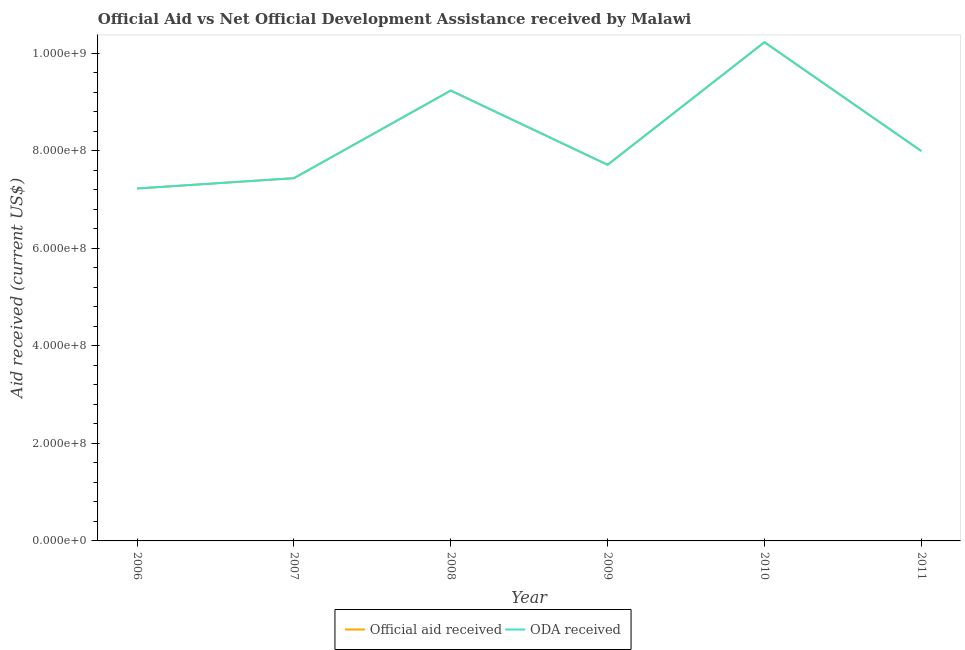Is the number of lines equal to the number of legend labels?
Offer a terse response. Yes. What is the oda received in 2006?
Offer a very short reply. 7.23e+08. Across all years, what is the maximum official aid received?
Give a very brief answer. 1.02e+09. Across all years, what is the minimum oda received?
Your response must be concise. 7.23e+08. What is the total oda received in the graph?
Offer a very short reply. 4.98e+09. What is the difference between the oda received in 2008 and that in 2009?
Ensure brevity in your answer.  1.52e+08. What is the difference between the official aid received in 2007 and the oda received in 2011?
Ensure brevity in your answer.  -5.57e+07. What is the average official aid received per year?
Provide a succinct answer. 8.31e+08. In the year 2007, what is the difference between the oda received and official aid received?
Offer a terse response. 0. What is the ratio of the official aid received in 2007 to that in 2010?
Give a very brief answer. 0.73. What is the difference between the highest and the second highest oda received?
Provide a succinct answer. 9.92e+07. What is the difference between the highest and the lowest oda received?
Keep it short and to the point. 3.00e+08. In how many years, is the oda received greater than the average oda received taken over all years?
Your answer should be very brief. 2. Are the values on the major ticks of Y-axis written in scientific E-notation?
Keep it short and to the point. Yes. Does the graph contain any zero values?
Offer a terse response. No. Where does the legend appear in the graph?
Your response must be concise. Bottom center. How are the legend labels stacked?
Ensure brevity in your answer.  Horizontal. What is the title of the graph?
Your answer should be compact. Official Aid vs Net Official Development Assistance received by Malawi . Does "All education staff compensation" appear as one of the legend labels in the graph?
Keep it short and to the point. No. What is the label or title of the Y-axis?
Make the answer very short. Aid received (current US$). What is the Aid received (current US$) of Official aid received in 2006?
Offer a very short reply. 7.23e+08. What is the Aid received (current US$) of ODA received in 2006?
Provide a succinct answer. 7.23e+08. What is the Aid received (current US$) in Official aid received in 2007?
Offer a terse response. 7.44e+08. What is the Aid received (current US$) in ODA received in 2007?
Give a very brief answer. 7.44e+08. What is the Aid received (current US$) of Official aid received in 2008?
Provide a succinct answer. 9.24e+08. What is the Aid received (current US$) of ODA received in 2008?
Make the answer very short. 9.24e+08. What is the Aid received (current US$) in Official aid received in 2009?
Your answer should be compact. 7.71e+08. What is the Aid received (current US$) of ODA received in 2009?
Ensure brevity in your answer.  7.71e+08. What is the Aid received (current US$) of Official aid received in 2010?
Your response must be concise. 1.02e+09. What is the Aid received (current US$) in ODA received in 2010?
Keep it short and to the point. 1.02e+09. What is the Aid received (current US$) in Official aid received in 2011?
Make the answer very short. 8.00e+08. What is the Aid received (current US$) in ODA received in 2011?
Offer a terse response. 8.00e+08. Across all years, what is the maximum Aid received (current US$) in Official aid received?
Offer a very short reply. 1.02e+09. Across all years, what is the maximum Aid received (current US$) in ODA received?
Offer a very short reply. 1.02e+09. Across all years, what is the minimum Aid received (current US$) in Official aid received?
Keep it short and to the point. 7.23e+08. Across all years, what is the minimum Aid received (current US$) of ODA received?
Give a very brief answer. 7.23e+08. What is the total Aid received (current US$) in Official aid received in the graph?
Give a very brief answer. 4.98e+09. What is the total Aid received (current US$) in ODA received in the graph?
Make the answer very short. 4.98e+09. What is the difference between the Aid received (current US$) of Official aid received in 2006 and that in 2007?
Your answer should be compact. -2.12e+07. What is the difference between the Aid received (current US$) in ODA received in 2006 and that in 2007?
Your answer should be compact. -2.12e+07. What is the difference between the Aid received (current US$) in Official aid received in 2006 and that in 2008?
Provide a short and direct response. -2.01e+08. What is the difference between the Aid received (current US$) of ODA received in 2006 and that in 2008?
Keep it short and to the point. -2.01e+08. What is the difference between the Aid received (current US$) in Official aid received in 2006 and that in 2009?
Your answer should be very brief. -4.86e+07. What is the difference between the Aid received (current US$) in ODA received in 2006 and that in 2009?
Keep it short and to the point. -4.86e+07. What is the difference between the Aid received (current US$) of Official aid received in 2006 and that in 2010?
Offer a terse response. -3.00e+08. What is the difference between the Aid received (current US$) in ODA received in 2006 and that in 2010?
Provide a succinct answer. -3.00e+08. What is the difference between the Aid received (current US$) in Official aid received in 2006 and that in 2011?
Offer a terse response. -7.68e+07. What is the difference between the Aid received (current US$) of ODA received in 2006 and that in 2011?
Ensure brevity in your answer.  -7.68e+07. What is the difference between the Aid received (current US$) of Official aid received in 2007 and that in 2008?
Your answer should be very brief. -1.80e+08. What is the difference between the Aid received (current US$) of ODA received in 2007 and that in 2008?
Your response must be concise. -1.80e+08. What is the difference between the Aid received (current US$) in Official aid received in 2007 and that in 2009?
Your response must be concise. -2.74e+07. What is the difference between the Aid received (current US$) in ODA received in 2007 and that in 2009?
Keep it short and to the point. -2.74e+07. What is the difference between the Aid received (current US$) of Official aid received in 2007 and that in 2010?
Give a very brief answer. -2.79e+08. What is the difference between the Aid received (current US$) of ODA received in 2007 and that in 2010?
Your response must be concise. -2.79e+08. What is the difference between the Aid received (current US$) of Official aid received in 2007 and that in 2011?
Ensure brevity in your answer.  -5.57e+07. What is the difference between the Aid received (current US$) of ODA received in 2007 and that in 2011?
Provide a short and direct response. -5.57e+07. What is the difference between the Aid received (current US$) of Official aid received in 2008 and that in 2009?
Offer a terse response. 1.52e+08. What is the difference between the Aid received (current US$) in ODA received in 2008 and that in 2009?
Your answer should be compact. 1.52e+08. What is the difference between the Aid received (current US$) in Official aid received in 2008 and that in 2010?
Provide a short and direct response. -9.92e+07. What is the difference between the Aid received (current US$) in ODA received in 2008 and that in 2010?
Keep it short and to the point. -9.92e+07. What is the difference between the Aid received (current US$) in Official aid received in 2008 and that in 2011?
Make the answer very short. 1.24e+08. What is the difference between the Aid received (current US$) in ODA received in 2008 and that in 2011?
Offer a terse response. 1.24e+08. What is the difference between the Aid received (current US$) in Official aid received in 2009 and that in 2010?
Offer a very short reply. -2.51e+08. What is the difference between the Aid received (current US$) in ODA received in 2009 and that in 2010?
Give a very brief answer. -2.51e+08. What is the difference between the Aid received (current US$) in Official aid received in 2009 and that in 2011?
Offer a terse response. -2.82e+07. What is the difference between the Aid received (current US$) in ODA received in 2009 and that in 2011?
Offer a very short reply. -2.82e+07. What is the difference between the Aid received (current US$) in Official aid received in 2010 and that in 2011?
Your response must be concise. 2.23e+08. What is the difference between the Aid received (current US$) in ODA received in 2010 and that in 2011?
Offer a very short reply. 2.23e+08. What is the difference between the Aid received (current US$) in Official aid received in 2006 and the Aid received (current US$) in ODA received in 2007?
Offer a very short reply. -2.12e+07. What is the difference between the Aid received (current US$) of Official aid received in 2006 and the Aid received (current US$) of ODA received in 2008?
Ensure brevity in your answer.  -2.01e+08. What is the difference between the Aid received (current US$) of Official aid received in 2006 and the Aid received (current US$) of ODA received in 2009?
Your answer should be compact. -4.86e+07. What is the difference between the Aid received (current US$) in Official aid received in 2006 and the Aid received (current US$) in ODA received in 2010?
Your answer should be compact. -3.00e+08. What is the difference between the Aid received (current US$) in Official aid received in 2006 and the Aid received (current US$) in ODA received in 2011?
Offer a terse response. -7.68e+07. What is the difference between the Aid received (current US$) in Official aid received in 2007 and the Aid received (current US$) in ODA received in 2008?
Offer a very short reply. -1.80e+08. What is the difference between the Aid received (current US$) of Official aid received in 2007 and the Aid received (current US$) of ODA received in 2009?
Provide a succinct answer. -2.74e+07. What is the difference between the Aid received (current US$) in Official aid received in 2007 and the Aid received (current US$) in ODA received in 2010?
Your answer should be compact. -2.79e+08. What is the difference between the Aid received (current US$) in Official aid received in 2007 and the Aid received (current US$) in ODA received in 2011?
Give a very brief answer. -5.57e+07. What is the difference between the Aid received (current US$) of Official aid received in 2008 and the Aid received (current US$) of ODA received in 2009?
Offer a very short reply. 1.52e+08. What is the difference between the Aid received (current US$) of Official aid received in 2008 and the Aid received (current US$) of ODA received in 2010?
Your response must be concise. -9.92e+07. What is the difference between the Aid received (current US$) in Official aid received in 2008 and the Aid received (current US$) in ODA received in 2011?
Offer a terse response. 1.24e+08. What is the difference between the Aid received (current US$) in Official aid received in 2009 and the Aid received (current US$) in ODA received in 2010?
Provide a succinct answer. -2.51e+08. What is the difference between the Aid received (current US$) in Official aid received in 2009 and the Aid received (current US$) in ODA received in 2011?
Your answer should be compact. -2.82e+07. What is the difference between the Aid received (current US$) in Official aid received in 2010 and the Aid received (current US$) in ODA received in 2011?
Give a very brief answer. 2.23e+08. What is the average Aid received (current US$) in Official aid received per year?
Give a very brief answer. 8.31e+08. What is the average Aid received (current US$) of ODA received per year?
Provide a short and direct response. 8.31e+08. In the year 2006, what is the difference between the Aid received (current US$) of Official aid received and Aid received (current US$) of ODA received?
Keep it short and to the point. 0. In the year 2007, what is the difference between the Aid received (current US$) of Official aid received and Aid received (current US$) of ODA received?
Make the answer very short. 0. In the year 2008, what is the difference between the Aid received (current US$) of Official aid received and Aid received (current US$) of ODA received?
Provide a short and direct response. 0. What is the ratio of the Aid received (current US$) of Official aid received in 2006 to that in 2007?
Ensure brevity in your answer.  0.97. What is the ratio of the Aid received (current US$) of ODA received in 2006 to that in 2007?
Ensure brevity in your answer.  0.97. What is the ratio of the Aid received (current US$) of Official aid received in 2006 to that in 2008?
Offer a terse response. 0.78. What is the ratio of the Aid received (current US$) of ODA received in 2006 to that in 2008?
Make the answer very short. 0.78. What is the ratio of the Aid received (current US$) of Official aid received in 2006 to that in 2009?
Offer a very short reply. 0.94. What is the ratio of the Aid received (current US$) in ODA received in 2006 to that in 2009?
Your answer should be compact. 0.94. What is the ratio of the Aid received (current US$) in Official aid received in 2006 to that in 2010?
Keep it short and to the point. 0.71. What is the ratio of the Aid received (current US$) of ODA received in 2006 to that in 2010?
Provide a succinct answer. 0.71. What is the ratio of the Aid received (current US$) in Official aid received in 2006 to that in 2011?
Offer a terse response. 0.9. What is the ratio of the Aid received (current US$) in ODA received in 2006 to that in 2011?
Provide a short and direct response. 0.9. What is the ratio of the Aid received (current US$) in Official aid received in 2007 to that in 2008?
Provide a short and direct response. 0.81. What is the ratio of the Aid received (current US$) of ODA received in 2007 to that in 2008?
Provide a succinct answer. 0.81. What is the ratio of the Aid received (current US$) in Official aid received in 2007 to that in 2009?
Keep it short and to the point. 0.96. What is the ratio of the Aid received (current US$) in ODA received in 2007 to that in 2009?
Your response must be concise. 0.96. What is the ratio of the Aid received (current US$) of Official aid received in 2007 to that in 2010?
Offer a terse response. 0.73. What is the ratio of the Aid received (current US$) of ODA received in 2007 to that in 2010?
Provide a succinct answer. 0.73. What is the ratio of the Aid received (current US$) of Official aid received in 2007 to that in 2011?
Give a very brief answer. 0.93. What is the ratio of the Aid received (current US$) of ODA received in 2007 to that in 2011?
Your answer should be compact. 0.93. What is the ratio of the Aid received (current US$) of Official aid received in 2008 to that in 2009?
Your answer should be very brief. 1.2. What is the ratio of the Aid received (current US$) of ODA received in 2008 to that in 2009?
Your answer should be compact. 1.2. What is the ratio of the Aid received (current US$) of Official aid received in 2008 to that in 2010?
Provide a short and direct response. 0.9. What is the ratio of the Aid received (current US$) in ODA received in 2008 to that in 2010?
Give a very brief answer. 0.9. What is the ratio of the Aid received (current US$) of Official aid received in 2008 to that in 2011?
Make the answer very short. 1.16. What is the ratio of the Aid received (current US$) of ODA received in 2008 to that in 2011?
Keep it short and to the point. 1.16. What is the ratio of the Aid received (current US$) of Official aid received in 2009 to that in 2010?
Offer a terse response. 0.75. What is the ratio of the Aid received (current US$) of ODA received in 2009 to that in 2010?
Make the answer very short. 0.75. What is the ratio of the Aid received (current US$) of Official aid received in 2009 to that in 2011?
Keep it short and to the point. 0.96. What is the ratio of the Aid received (current US$) of ODA received in 2009 to that in 2011?
Your answer should be very brief. 0.96. What is the ratio of the Aid received (current US$) of Official aid received in 2010 to that in 2011?
Your answer should be compact. 1.28. What is the ratio of the Aid received (current US$) in ODA received in 2010 to that in 2011?
Provide a succinct answer. 1.28. What is the difference between the highest and the second highest Aid received (current US$) of Official aid received?
Your answer should be compact. 9.92e+07. What is the difference between the highest and the second highest Aid received (current US$) of ODA received?
Offer a terse response. 9.92e+07. What is the difference between the highest and the lowest Aid received (current US$) of Official aid received?
Keep it short and to the point. 3.00e+08. What is the difference between the highest and the lowest Aid received (current US$) of ODA received?
Your answer should be very brief. 3.00e+08. 